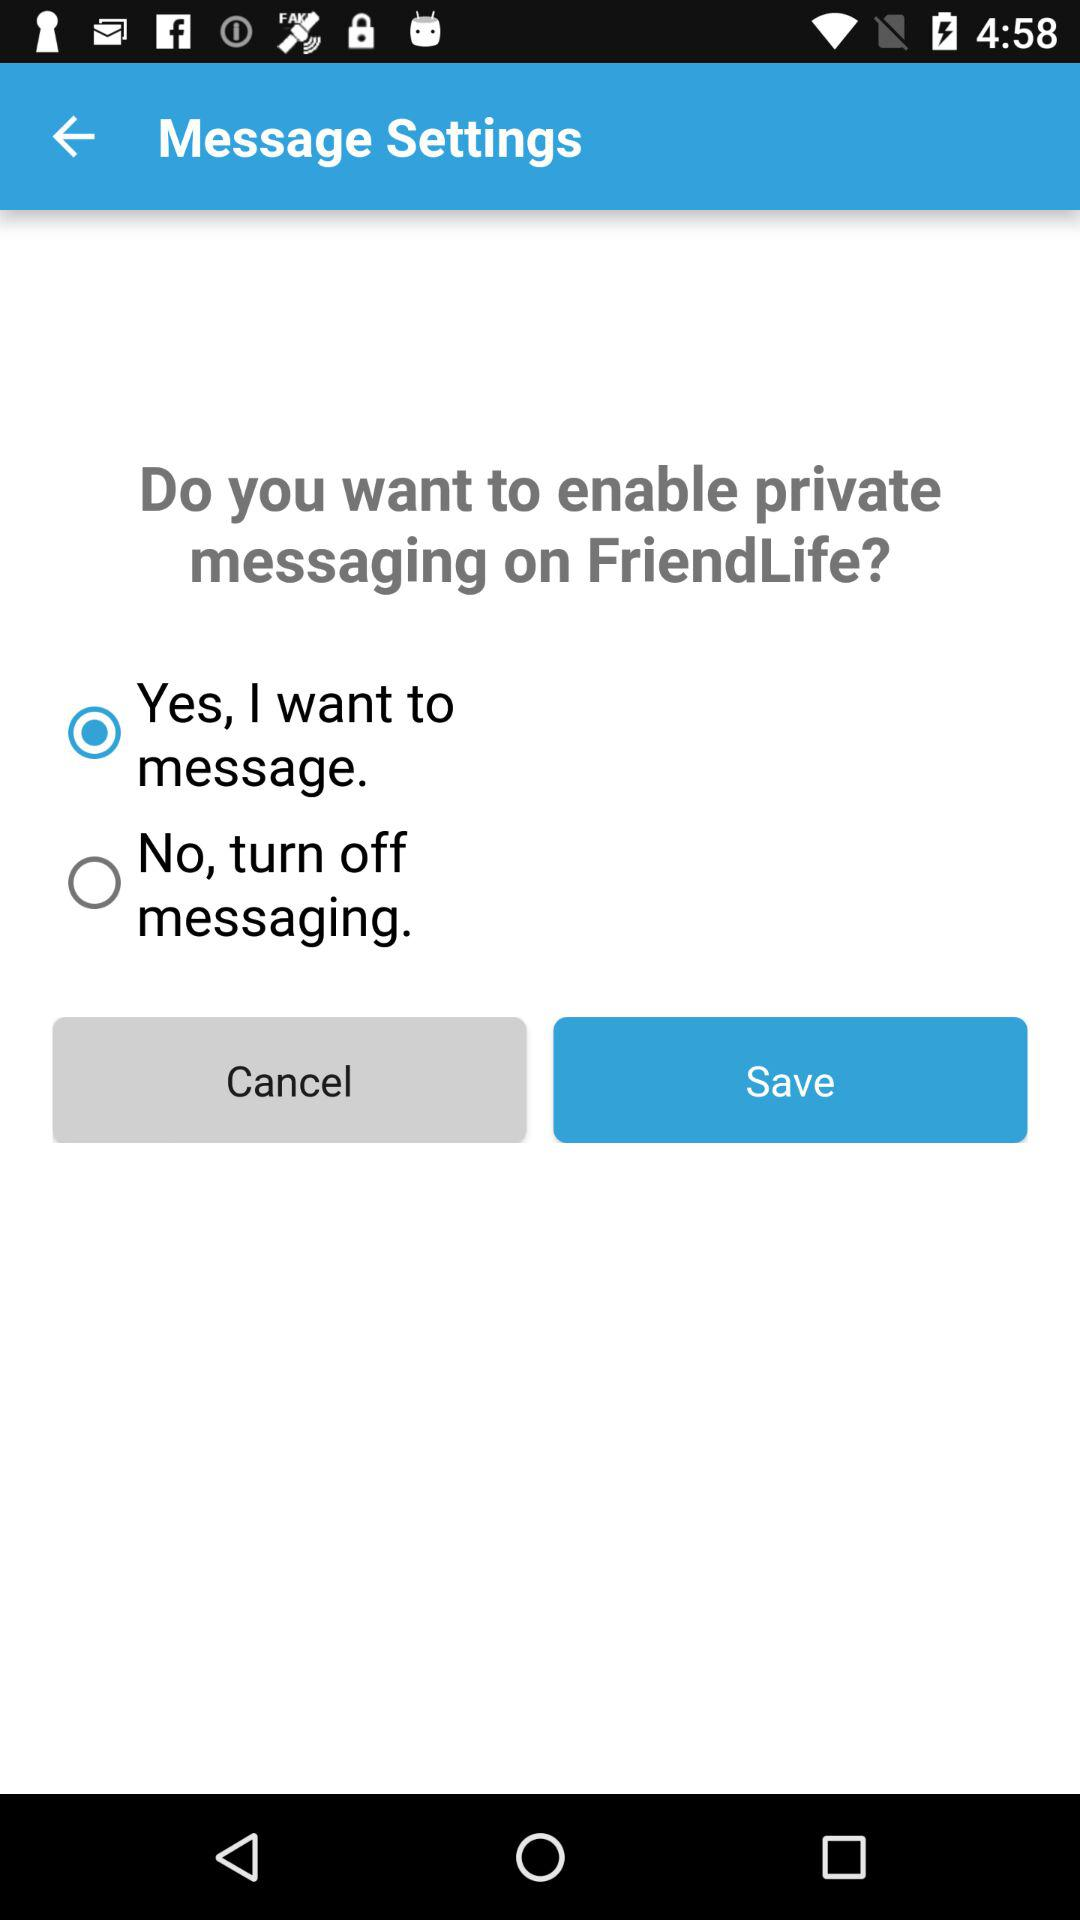What is the name of the application?
When the provided information is insufficient, respond with <no answer>. <no answer> 